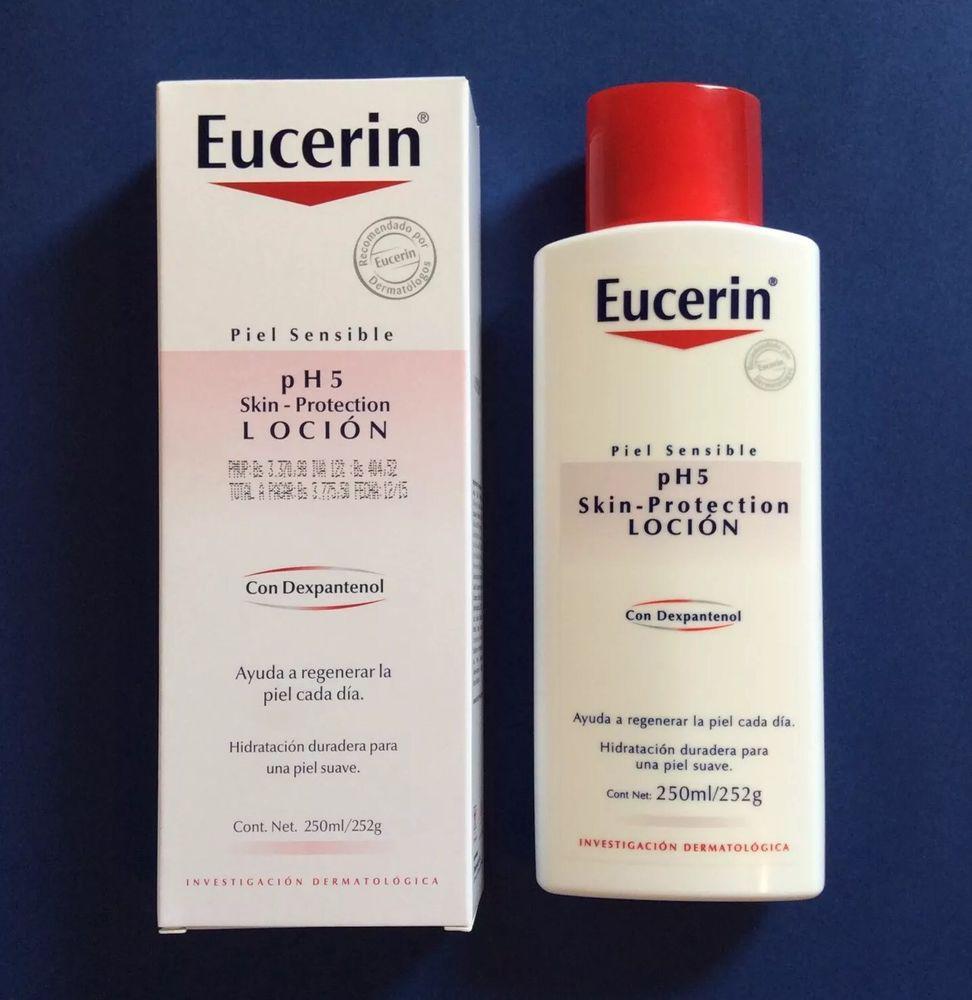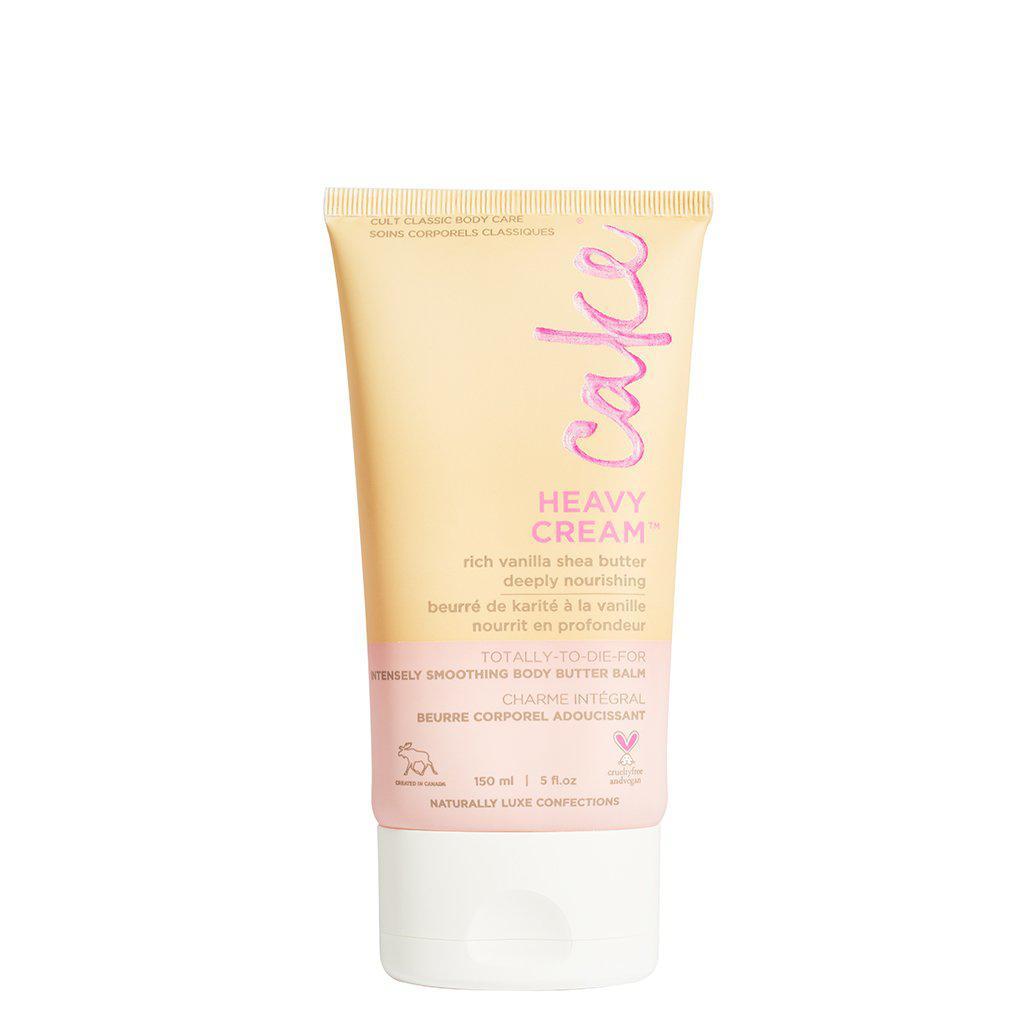The first image is the image on the left, the second image is the image on the right. Assess this claim about the two images: "One of the bottles has a pump dispenser on top.". Correct or not? Answer yes or no. No. The first image is the image on the left, the second image is the image on the right. Examine the images to the left and right. Is the description "One of the bottles has a pump cap." accurate? Answer yes or no. No. 